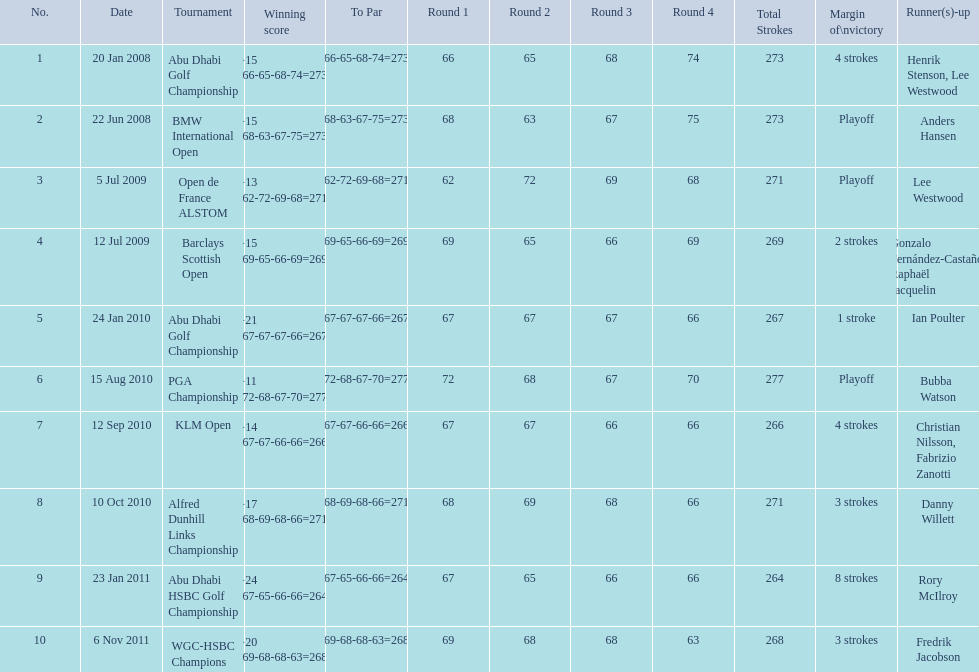How many strokes were in the klm open by martin kaymer? 4 strokes. How many strokes were in the abu dhabi golf championship? 4 strokes. How many more strokes were there in the klm than the barclays open? 2 strokes. 